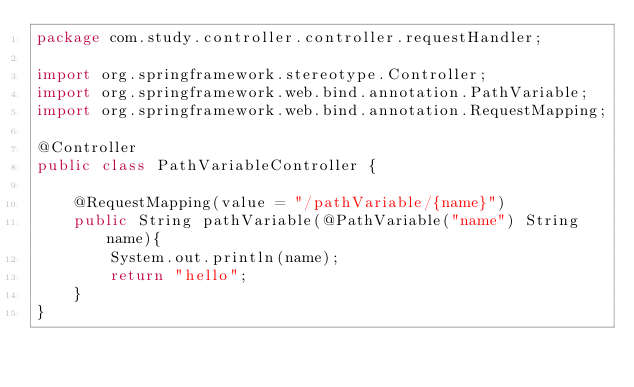<code> <loc_0><loc_0><loc_500><loc_500><_Java_>package com.study.controller.controller.requestHandler;

import org.springframework.stereotype.Controller;
import org.springframework.web.bind.annotation.PathVariable;
import org.springframework.web.bind.annotation.RequestMapping;

@Controller
public class PathVariableController {

    @RequestMapping(value = "/pathVariable/{name}")
    public String pathVariable(@PathVariable("name") String name){
        System.out.println(name);
        return "hello";
    }
}
</code> 